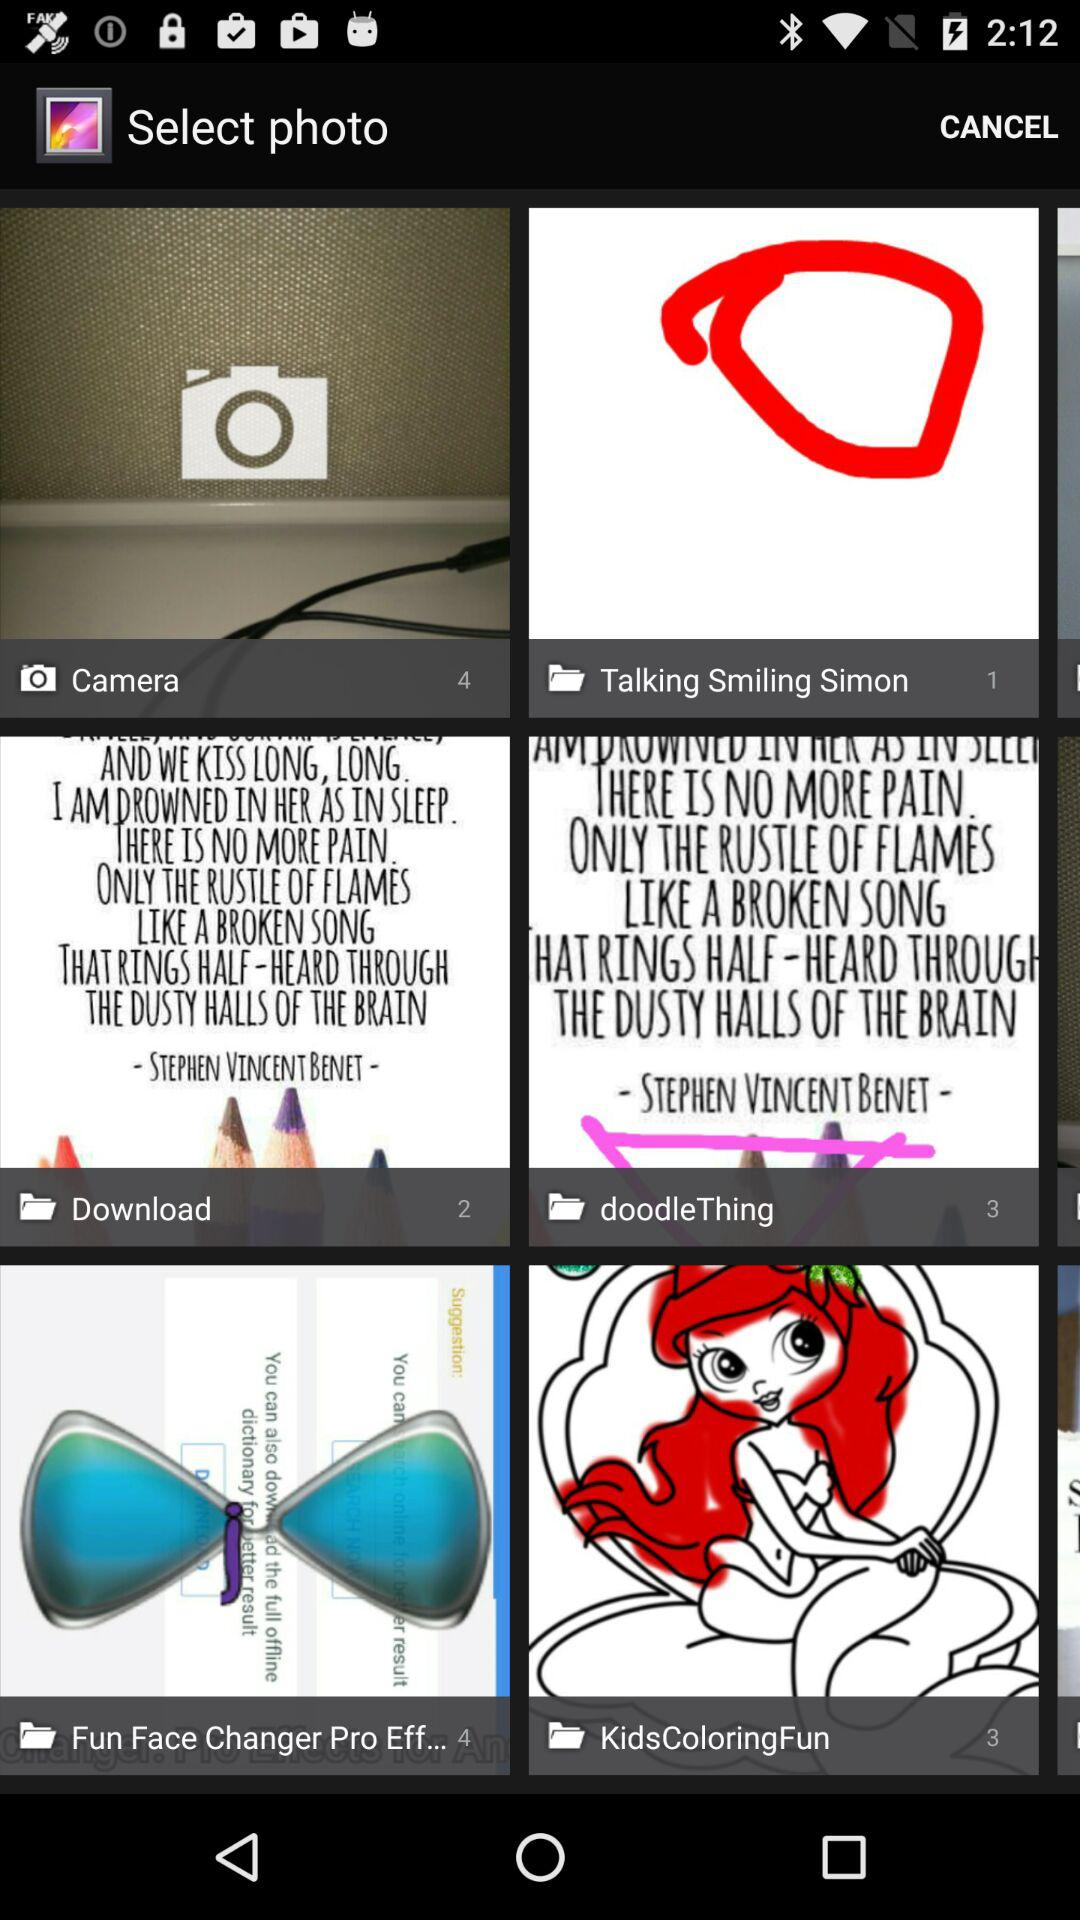What is the number of photos in the camera? The number of photos in the camera is 4. 